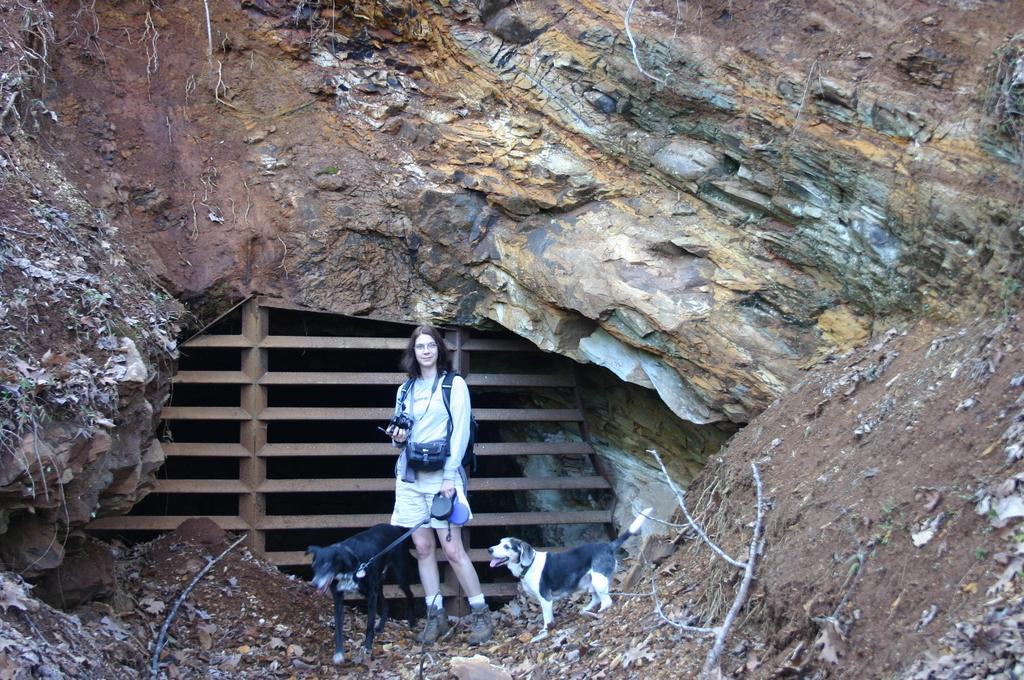What is the main subject of the image? There is a woman standing in the image. Are there any animals present in the image? Yes, there are two dogs in the image, one on each side of the woman. What type of terrain is visible in the image? There are stones visible in the image. What can be seen in the background of the image? There is a hill in the background of the image. What type of board is the woman using to wash the dogs in the image? There is no board or washing activity present in the image. 